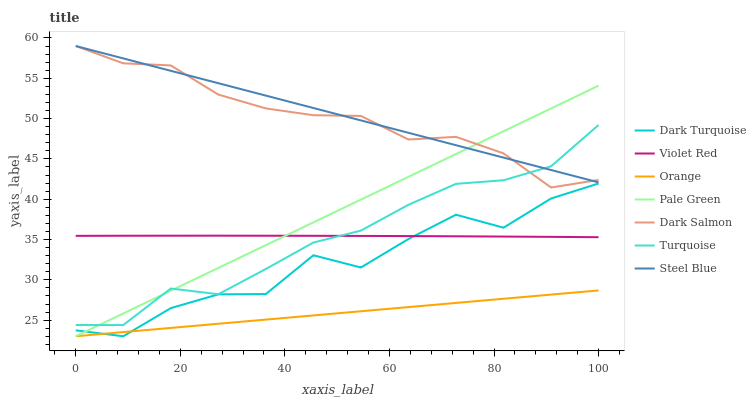Does Orange have the minimum area under the curve?
Answer yes or no. Yes. Does Steel Blue have the maximum area under the curve?
Answer yes or no. Yes. Does Dark Turquoise have the minimum area under the curve?
Answer yes or no. No. Does Dark Turquoise have the maximum area under the curve?
Answer yes or no. No. Is Orange the smoothest?
Answer yes or no. Yes. Is Dark Turquoise the roughest?
Answer yes or no. Yes. Is Dark Salmon the smoothest?
Answer yes or no. No. Is Dark Salmon the roughest?
Answer yes or no. No. Does Dark Turquoise have the lowest value?
Answer yes or no. Yes. Does Dark Salmon have the lowest value?
Answer yes or no. No. Does Steel Blue have the highest value?
Answer yes or no. Yes. Does Dark Turquoise have the highest value?
Answer yes or no. No. Is Violet Red less than Dark Salmon?
Answer yes or no. Yes. Is Dark Salmon greater than Violet Red?
Answer yes or no. Yes. Does Turquoise intersect Violet Red?
Answer yes or no. Yes. Is Turquoise less than Violet Red?
Answer yes or no. No. Is Turquoise greater than Violet Red?
Answer yes or no. No. Does Violet Red intersect Dark Salmon?
Answer yes or no. No. 